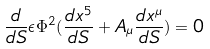Convert formula to latex. <formula><loc_0><loc_0><loc_500><loc_500>\frac { d } { d S } \epsilon \Phi ^ { 2 } ( \frac { d x ^ { 5 } } { d S } + A _ { \mu } \frac { d x ^ { \mu } } { d S } ) = 0</formula> 